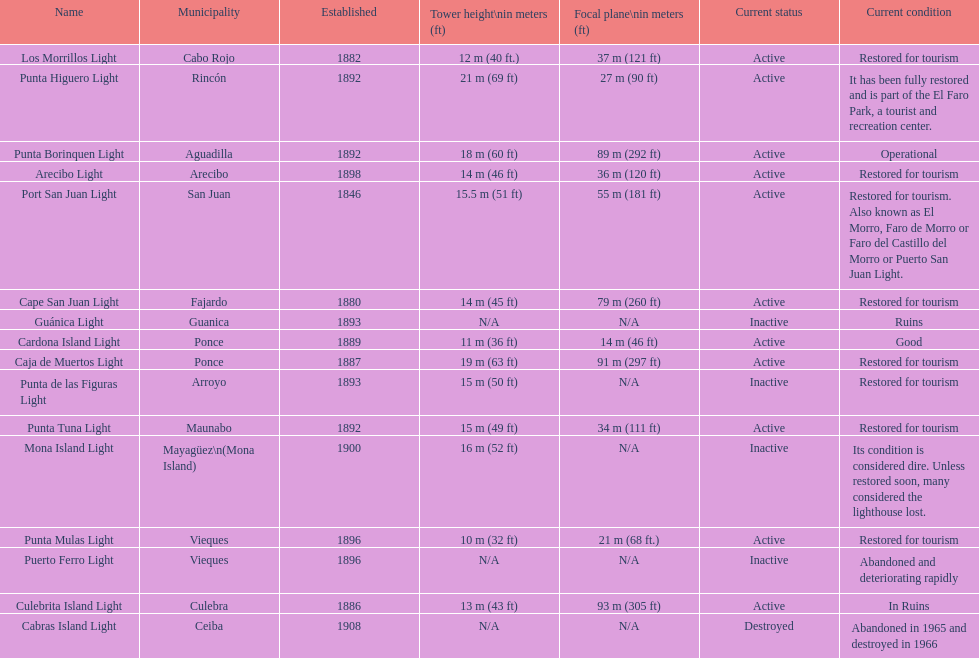How many towers are not shorter than 18 meters? 3. 